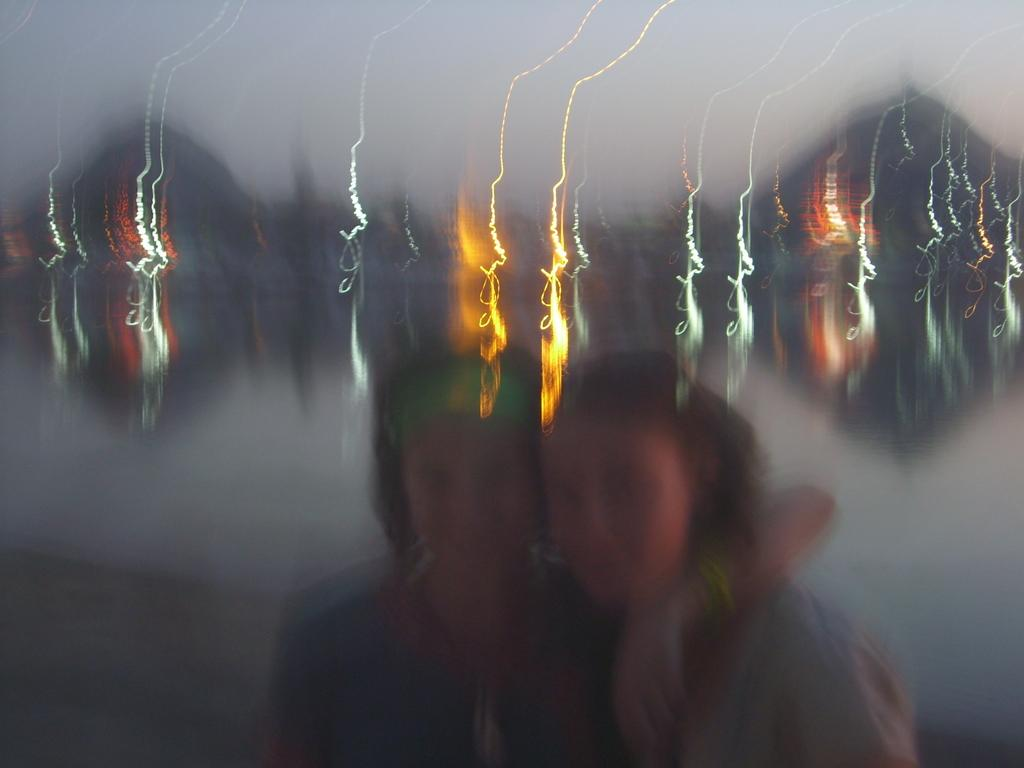How many people are in the image? There are two persons in the center of the image. What can be seen in the background of the image? There are lights visible in the background of the image. What type of secretary is present in the image? There is no secretary present in the image. What is the temperature of the room in the image? The provided facts do not mention the temperature or any indication of the room's temperature. 